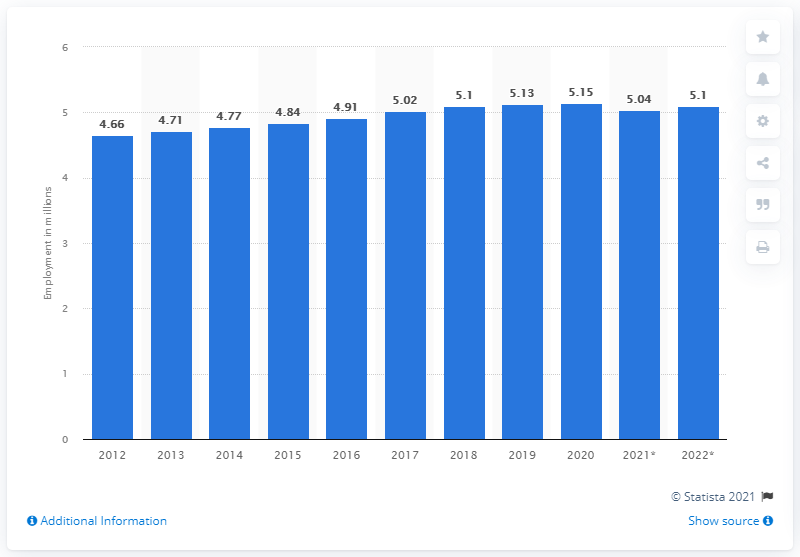Give some essential details in this illustration. The employment in Sweden ended in 2020. In 2020, approximately 5.1 million people were employed in Sweden. The employment in Sweden ended in 2020. 